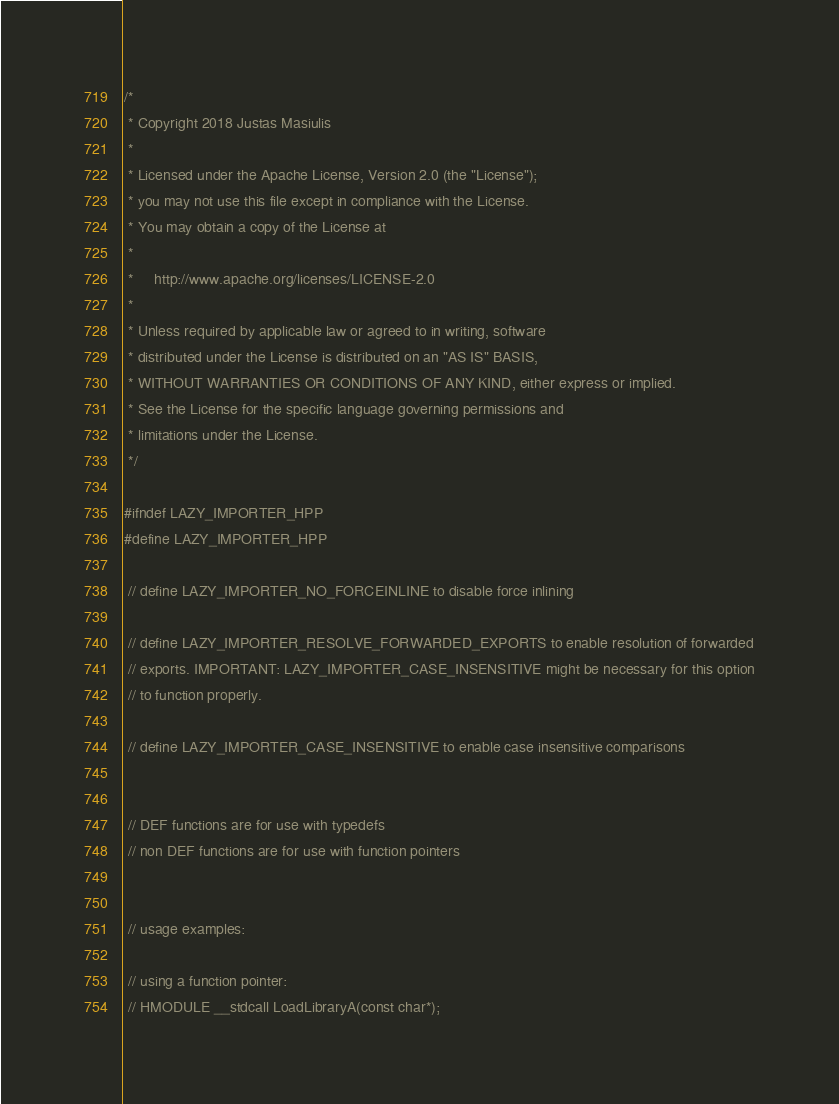<code> <loc_0><loc_0><loc_500><loc_500><_C++_>/*
 * Copyright 2018 Justas Masiulis
 *
 * Licensed under the Apache License, Version 2.0 (the "License");
 * you may not use this file except in compliance with the License.
 * You may obtain a copy of the License at
 *
 *     http://www.apache.org/licenses/LICENSE-2.0
 *
 * Unless required by applicable law or agreed to in writing, software
 * distributed under the License is distributed on an "AS IS" BASIS,
 * WITHOUT WARRANTIES OR CONDITIONS OF ANY KIND, either express or implied.
 * See the License for the specific language governing permissions and
 * limitations under the License.
 */

#ifndef LAZY_IMPORTER_HPP
#define LAZY_IMPORTER_HPP

 // define LAZY_IMPORTER_NO_FORCEINLINE to disable force inlining

 // define LAZY_IMPORTER_RESOLVE_FORWARDED_EXPORTS to enable resolution of forwarded
 // exports. IMPORTANT: LAZY_IMPORTER_CASE_INSENSITIVE might be necessary for this option
 // to function properly.

 // define LAZY_IMPORTER_CASE_INSENSITIVE to enable case insensitive comparisons


 // DEF functions are for use with typedefs
 // non DEF functions are for use with function pointers


 // usage examples:

 // using a function pointer:
 // HMODULE __stdcall LoadLibraryA(const char*);</code> 